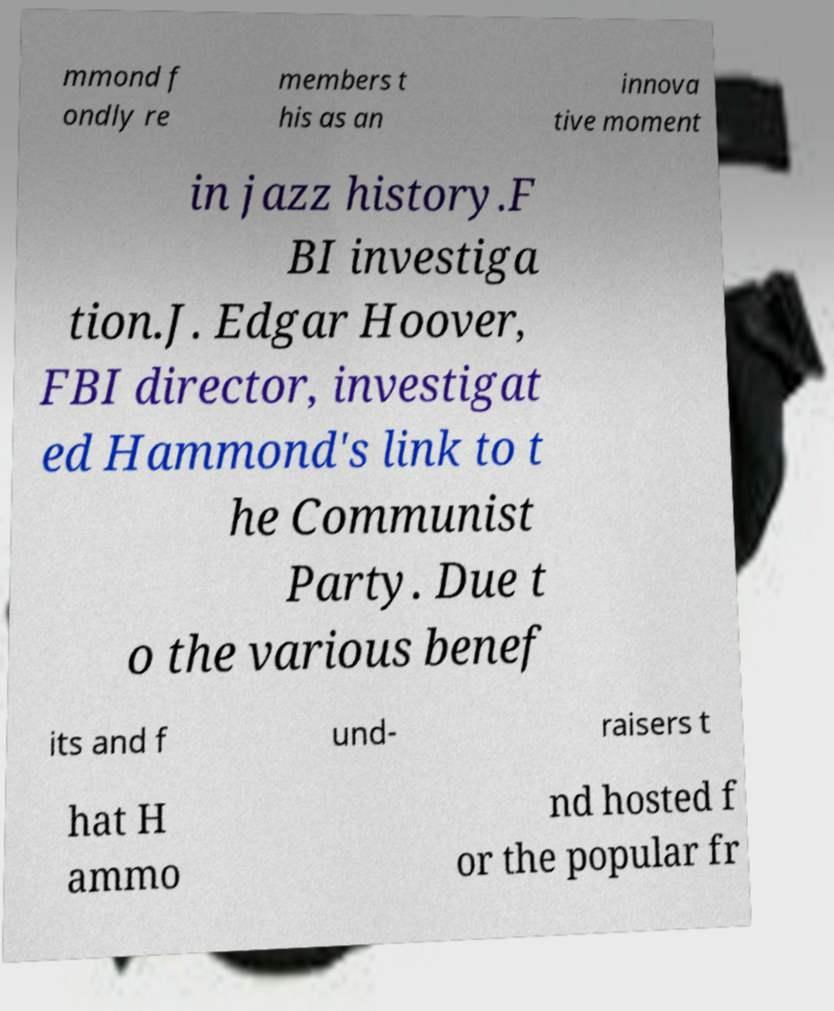What messages or text are displayed in this image? I need them in a readable, typed format. mmond f ondly re members t his as an innova tive moment in jazz history.F BI investiga tion.J. Edgar Hoover, FBI director, investigat ed Hammond's link to t he Communist Party. Due t o the various benef its and f und- raisers t hat H ammo nd hosted f or the popular fr 